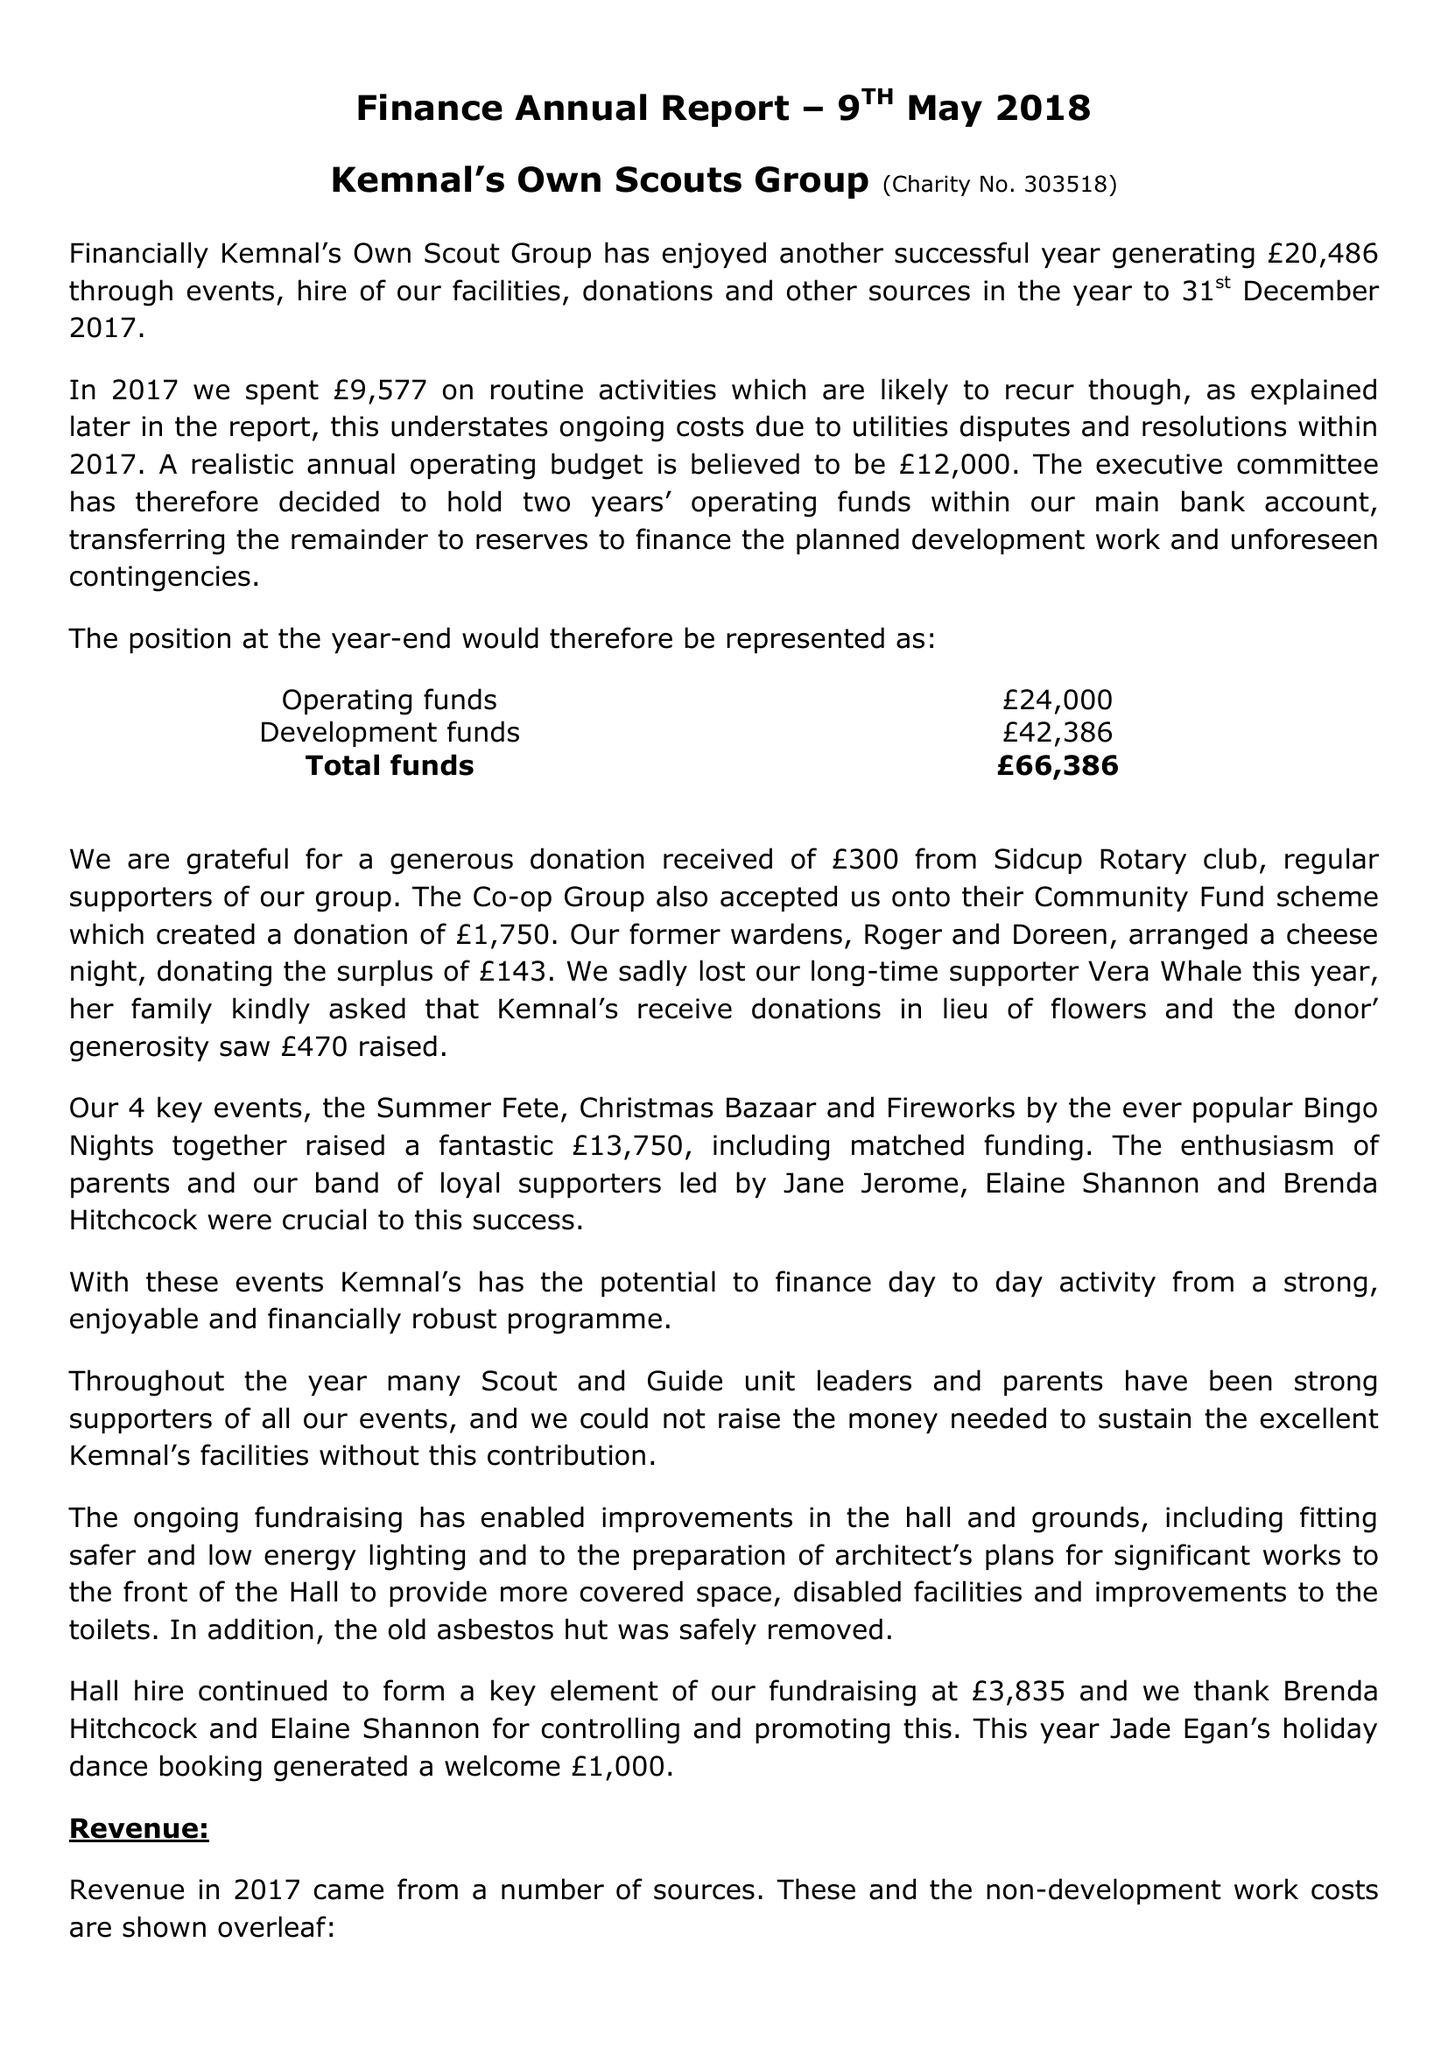What is the value for the address__postcode?
Answer the question using a single word or phrase. DA15 7NW 